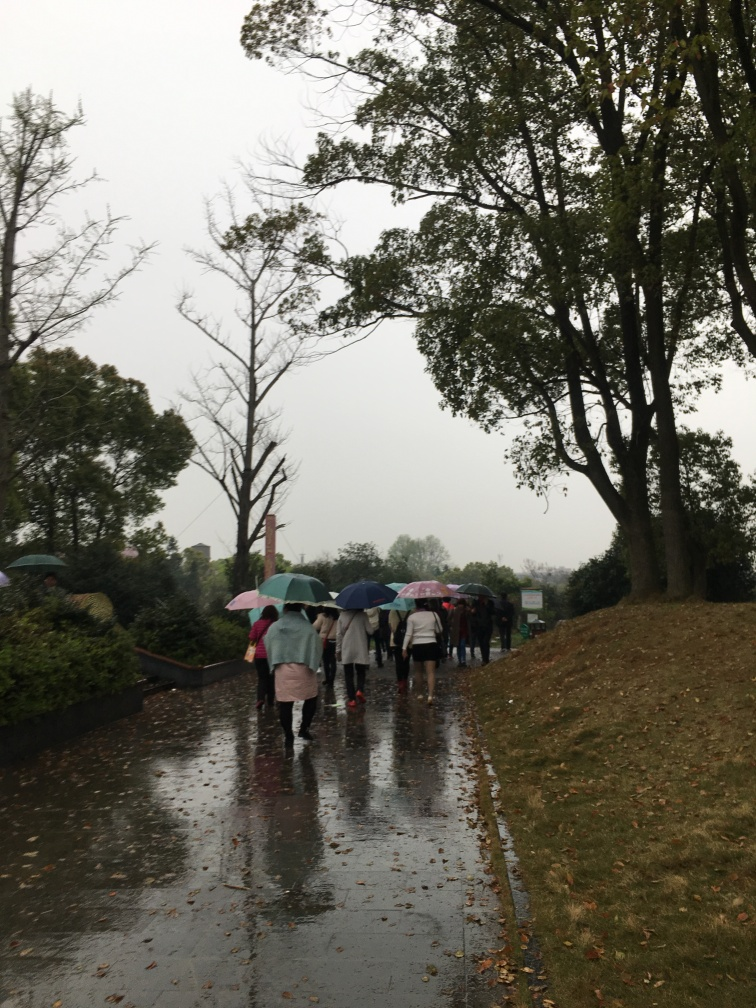What can this image tell us about the location it was taken in? This image depicts a pathway bordered by foliage and trees, suggesting a park or a similarly landscaped area in an urban setting. The attire of the individuals, use of umbrellas, and the reflective surface due to the rain, provides hints of a public, outdoor location in a region where rain is a common occurrence. Is it possible to estimate the time of the day or the season when this photo was taken? The overcast conditions and the lighting suggest it could be either early in the morning or later in the afternoon. The season is harder to determine, but the presence of fallen leaves and the attire of some individuals in light jackets may hint towards late fall or early spring. 